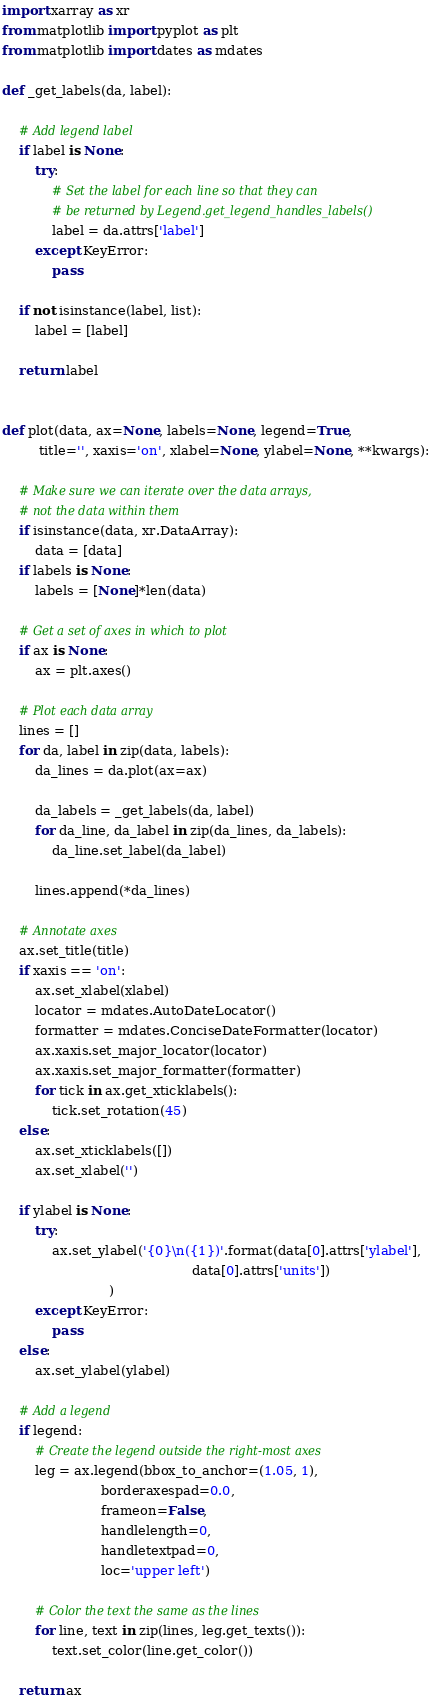Convert code to text. <code><loc_0><loc_0><loc_500><loc_500><_Python_>import xarray as xr
from matplotlib import pyplot as plt
from matplotlib import dates as mdates

def _get_labels(da, label):
    
    # Add legend label
    if label is None:
        try:
            # Set the label for each line so that they can
            # be returned by Legend.get_legend_handles_labels()
            label = da.attrs['label']
        except KeyError:
            pass

    if not isinstance(label, list):
        label = [label]
    
    return label


def plot(data, ax=None, labels=None, legend=True, 
         title='', xaxis='on', xlabel=None, ylabel=None, **kwargs):
    
    # Make sure we can iterate over the data arrays,
    # not the data within them
    if isinstance(data, xr.DataArray):
        data = [data]
    if labels is None:
        labels = [None]*len(data)
    
    # Get a set of axes in which to plot
    if ax is None:
        ax = plt.axes()
    
    # Plot each data array
    lines = []
    for da, label in zip(data, labels):
        da_lines = da.plot(ax=ax)
    
        da_labels = _get_labels(da, label)
        for da_line, da_label in zip(da_lines, da_labels):
            da_line.set_label(da_label)
    
        lines.append(*da_lines)
    
    # Annotate axes
    ax.set_title(title)
    if xaxis == 'on':
        ax.set_xlabel(xlabel)
        locator = mdates.AutoDateLocator()
        formatter = mdates.ConciseDateFormatter(locator)
        ax.xaxis.set_major_locator(locator)
        ax.xaxis.set_major_formatter(formatter)
        for tick in ax.get_xticklabels():
            tick.set_rotation(45)
    else:
        ax.set_xticklabels([])
        ax.set_xlabel('')
    
    if ylabel is None:
        try:
            ax.set_ylabel('{0}\n({1})'.format(data[0].attrs['ylabel'],
                                              data[0].attrs['units'])
                          )
        except KeyError:
            pass
    else:
        ax.set_ylabel(ylabel)
    
    # Add a legend
    if legend:
        # Create the legend outside the right-most axes
        leg = ax.legend(bbox_to_anchor=(1.05, 1),
                        borderaxespad=0.0,
                        frameon=False,
                        handlelength=0,
                        handletextpad=0,
                        loc='upper left')
        
        # Color the text the same as the lines
        for line, text in zip(lines, leg.get_texts()):
            text.set_color(line.get_color())
    
    return ax</code> 